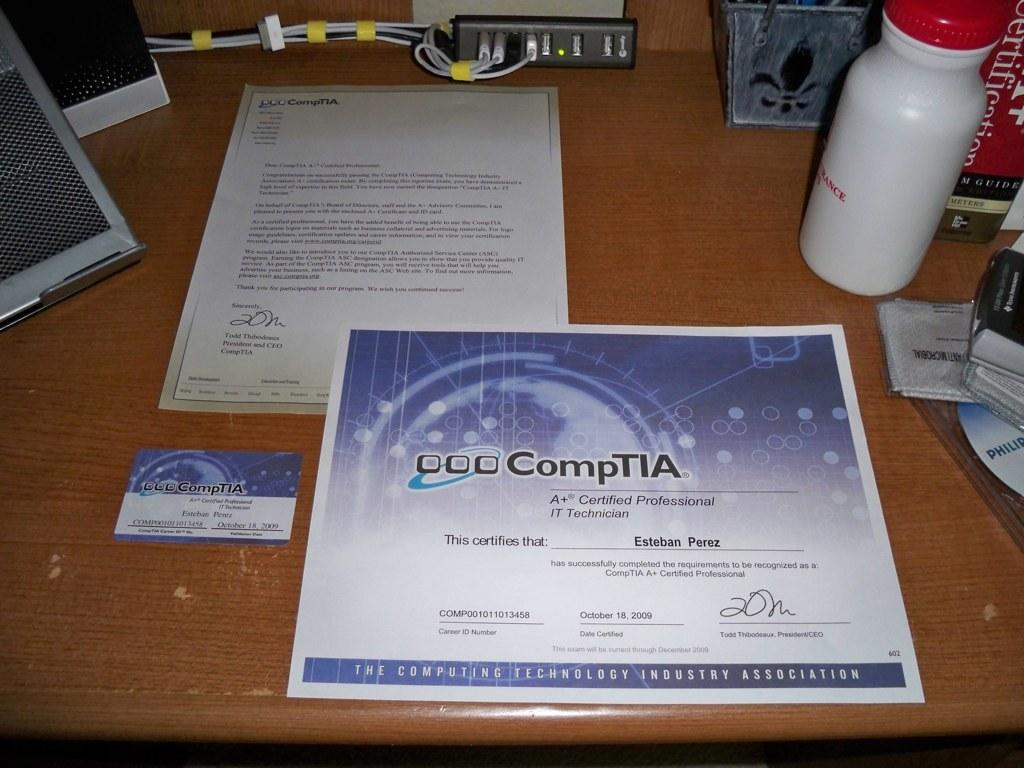<image>
Relay a brief, clear account of the picture shown. A + certification paper with a business card on a desk. 